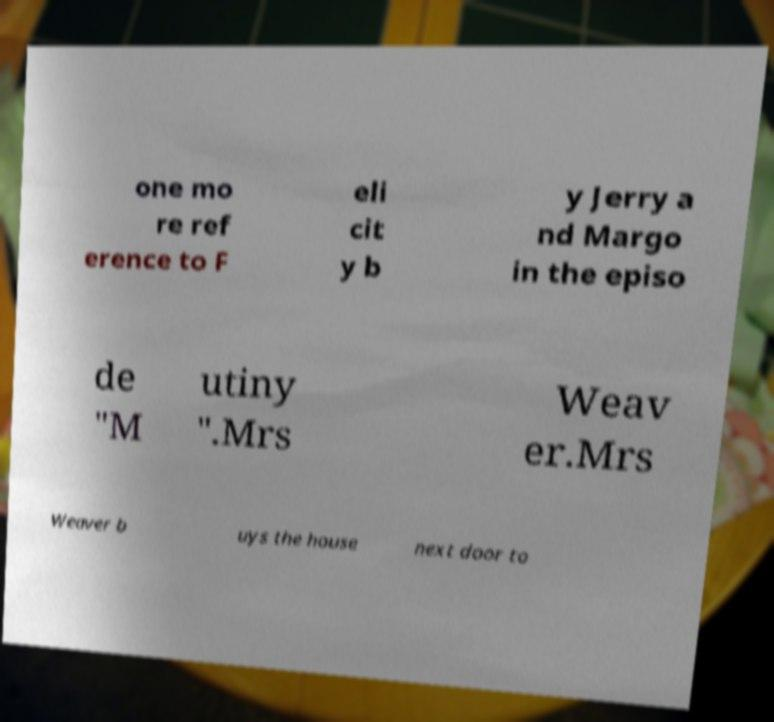Could you extract and type out the text from this image? one mo re ref erence to F eli cit y b y Jerry a nd Margo in the episo de "M utiny ".Mrs Weav er.Mrs Weaver b uys the house next door to 